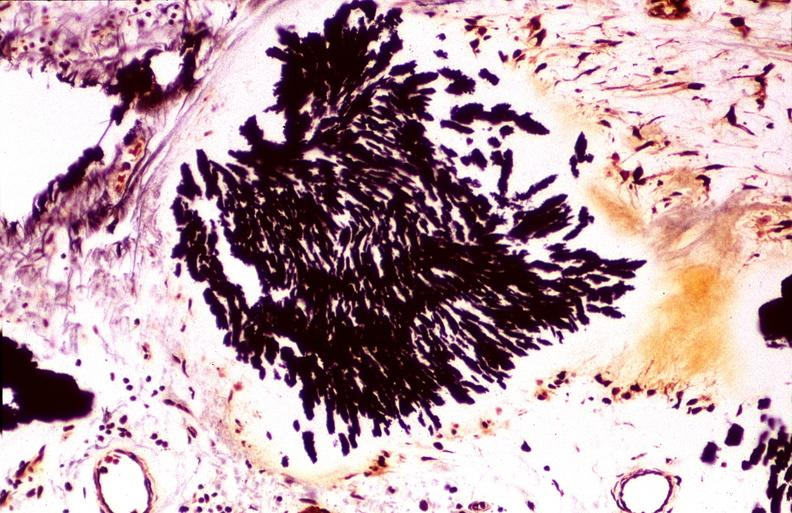what does this image show?
Answer the question using a single word or phrase. Gout 